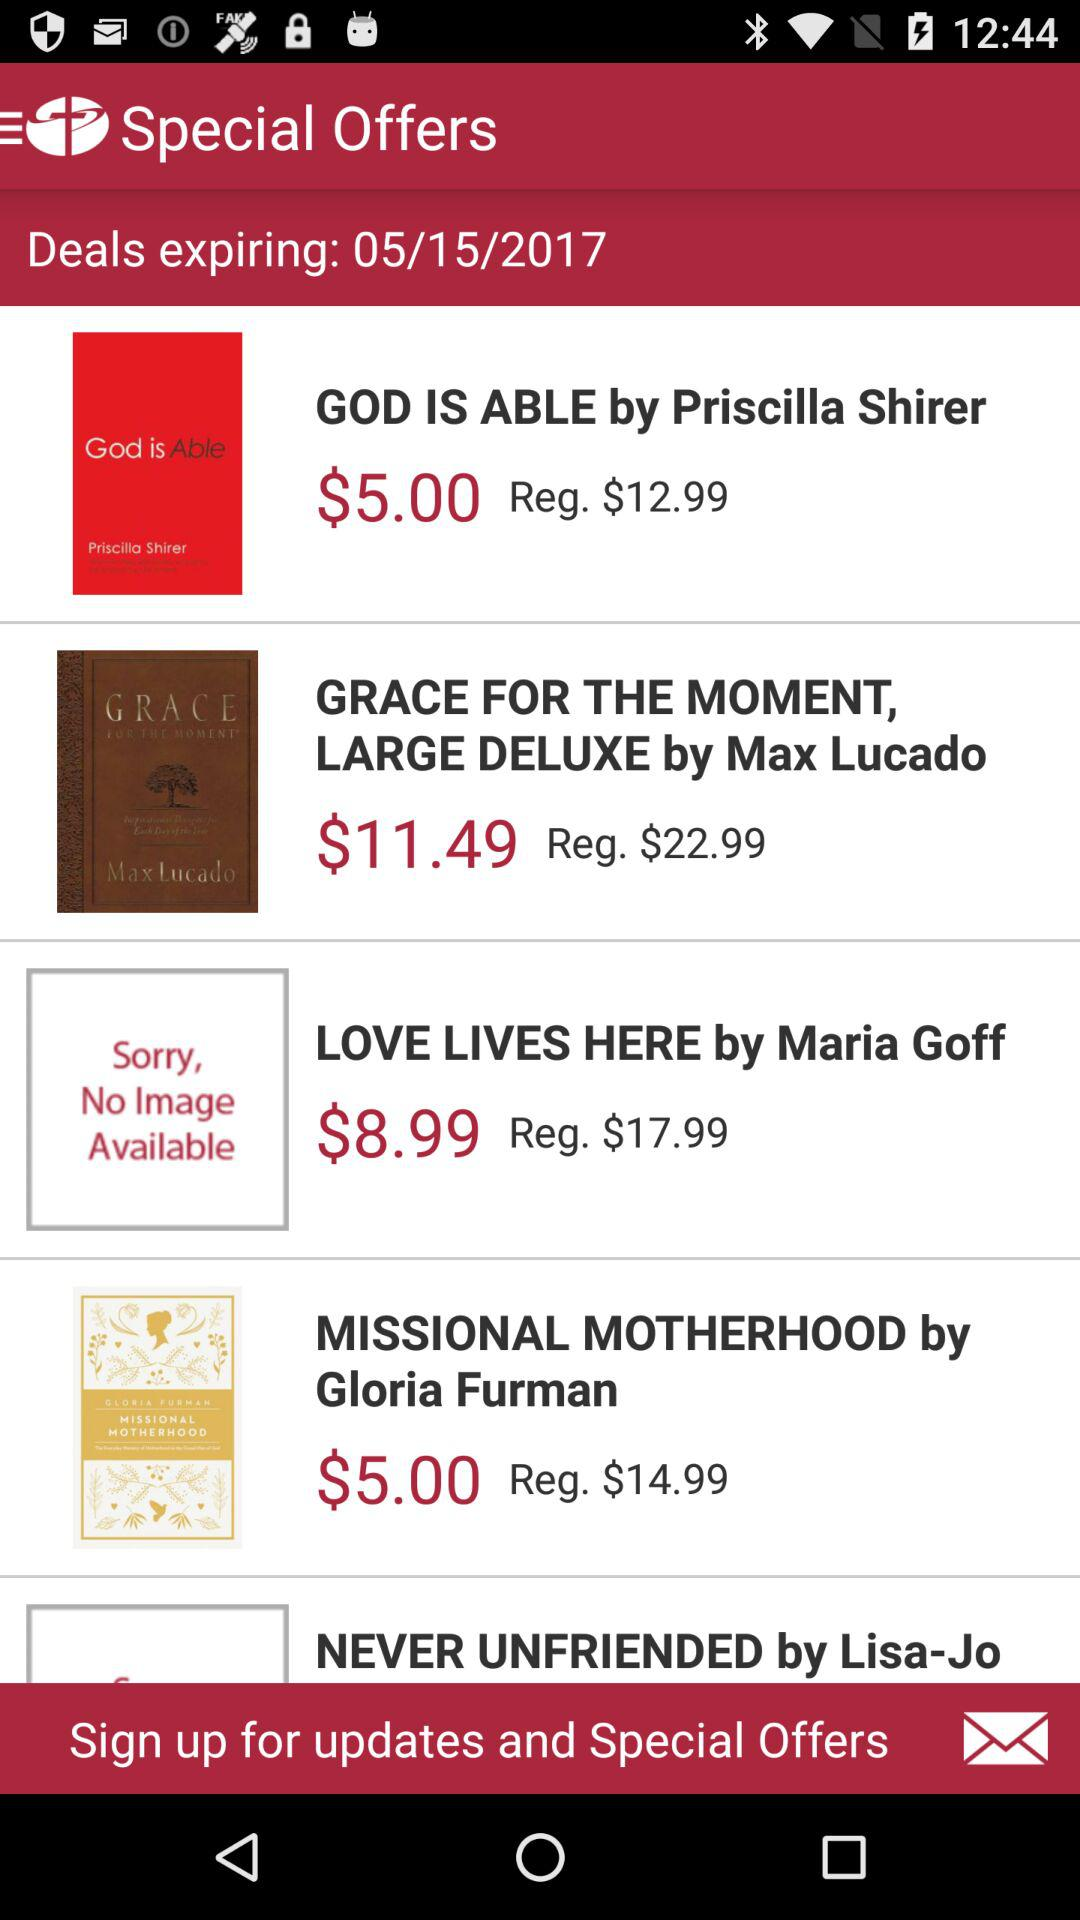What is the price of "LOVE LIVES HERE by Maria Goff"? The price of "LOVE LIVES HERE by Maria Goff" is $17.99. 